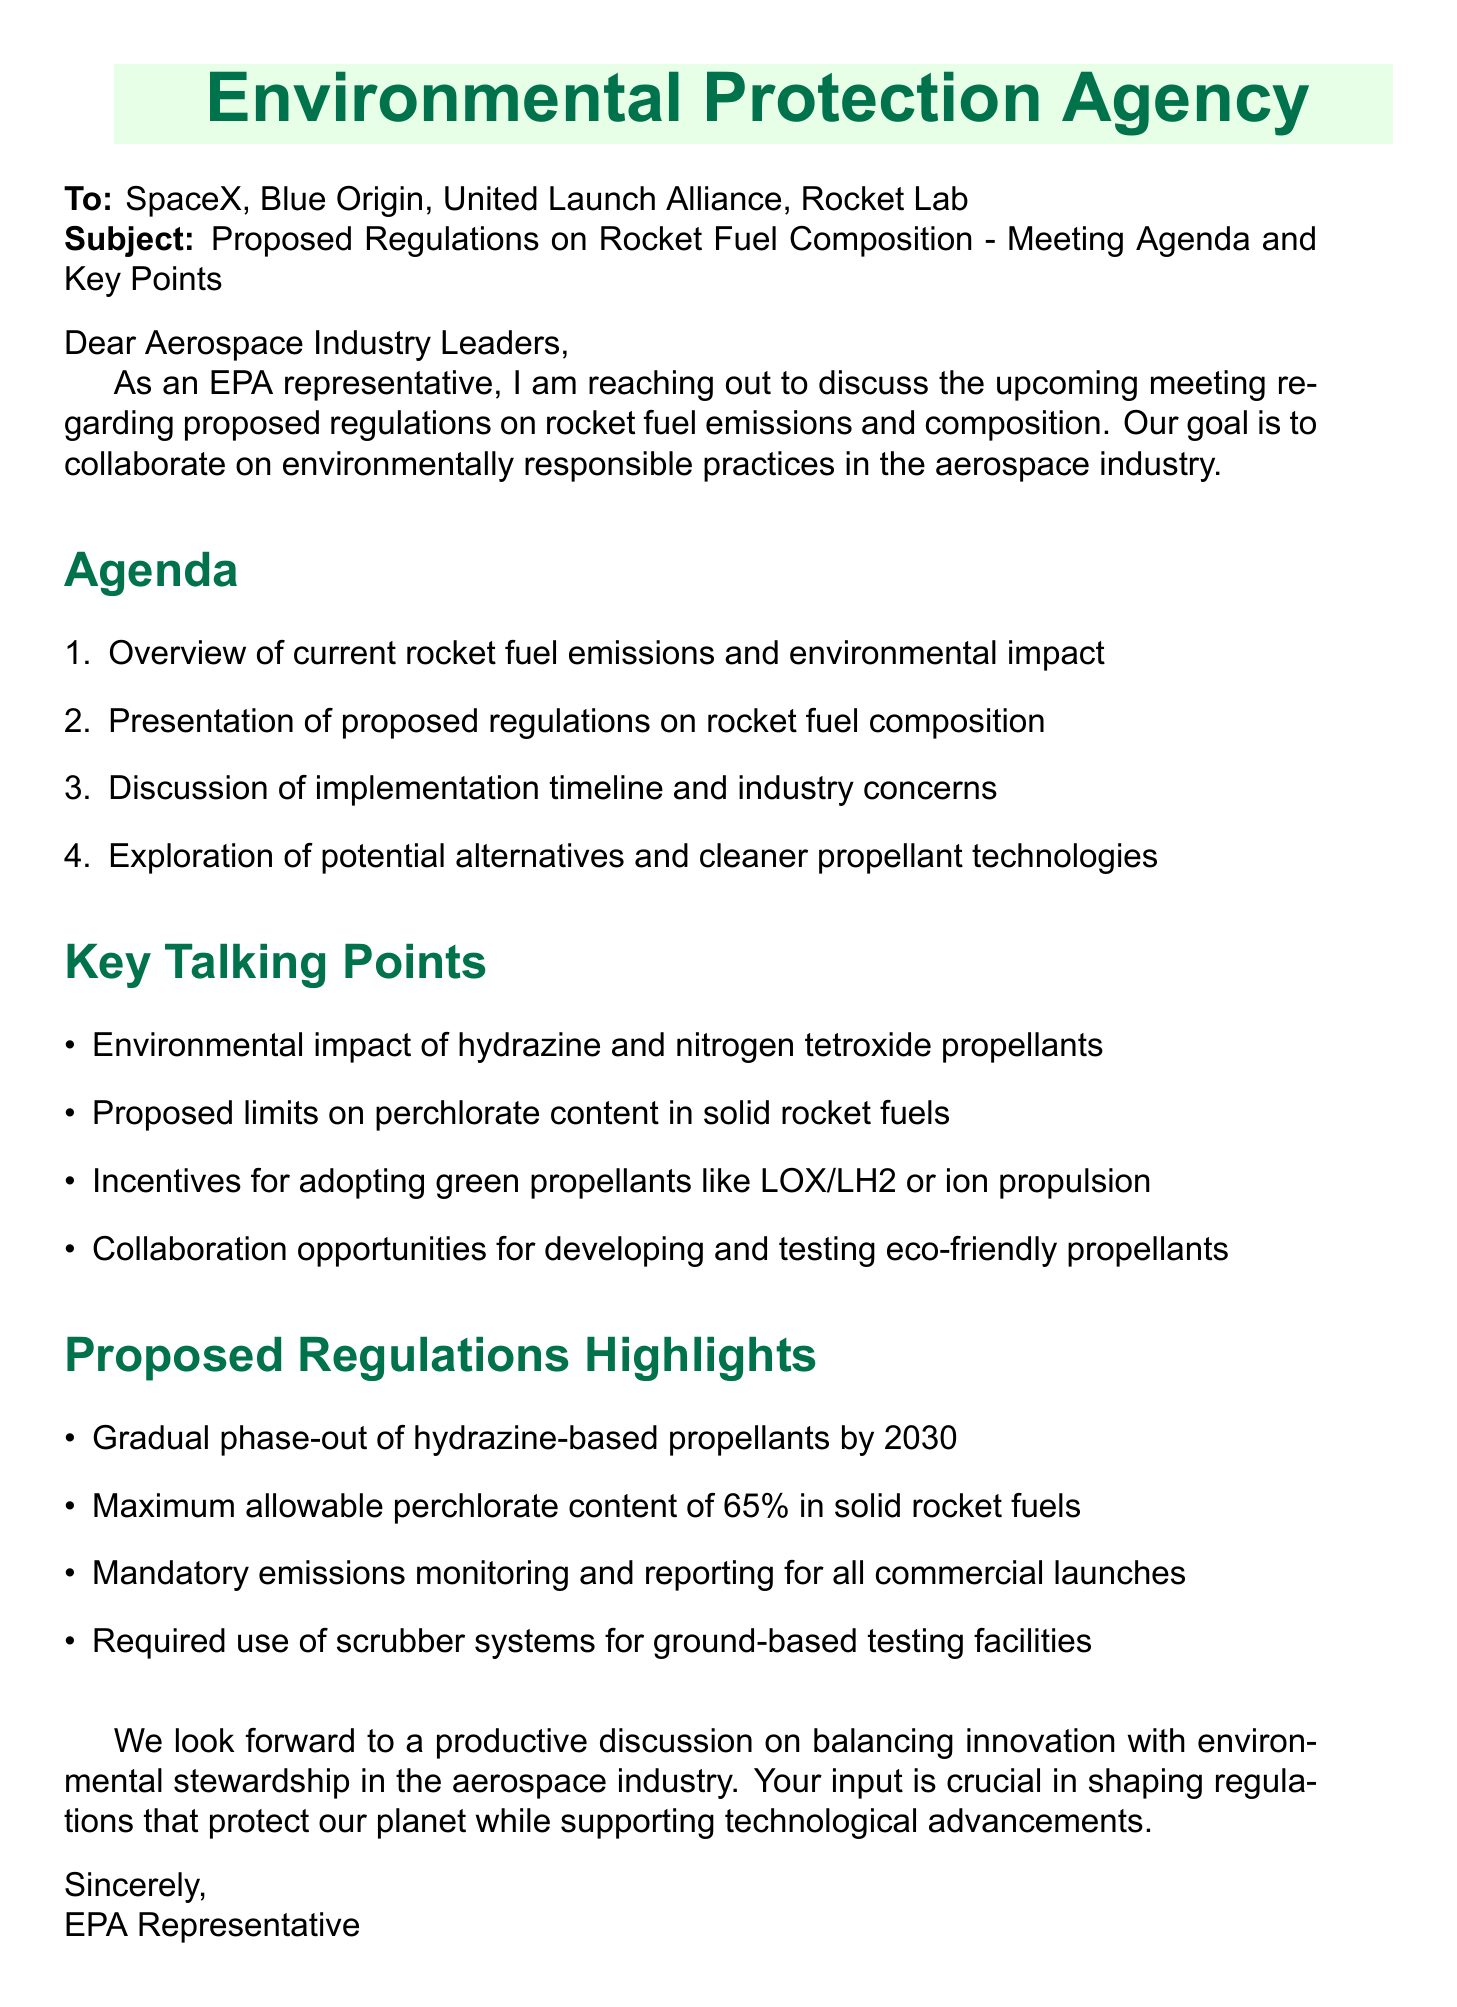What are the names of the companies invited to the meeting? The document lists the companies that are invited to the meeting, which include SpaceX, Blue Origin, United Launch Alliance, and Rocket Lab.
Answer: SpaceX, Blue Origin, United Launch Alliance, Rocket Lab What is the maximum allowable perchlorate content in solid rocket fuels? The proposed regulations highlight that the maximum allowable perchlorate content is specifically stated in the document.
Answer: 65% What is the timeline for the gradual phase-out of hydrazine-based propellants? The regulations propose a specific timeline for this phase-out, mentioned in the document.
Answer: by 2030 Who is the President of Blue Origin? The document provides the names and titles of representatives from the invited companies, including Blue Origin.
Answer: Bob Smith What is one of the key talking points regarding propellant technologies? The document presents several key talking points related to propellant technologies that the meeting will address.
Answer: Incentives for adopting green propellants like LOX/LH2 or ion propulsion What is the purpose of the upcoming meeting? The introduction of the document states the main objective for reaching out and the focus of the meeting.
Answer: Collaborate on environmentally responsible practices What is one proposed regulation to be discussed concerning emissions? The document details a specific regulation related to emissions that is highlighted among the proposed regulations.
Answer: Mandatory emissions monitoring and reporting for all commercial launches What will be discussed regarding the implementation timeline? A specific agenda item in the document mentions the exploration of industry concerns related to timing.
Answer: Discussion of implementation timeline and industry concerns 